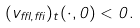<formula> <loc_0><loc_0><loc_500><loc_500>( v _ { \epsilon , \delta } ) _ { t } ( \cdot , 0 ) < 0 .</formula> 